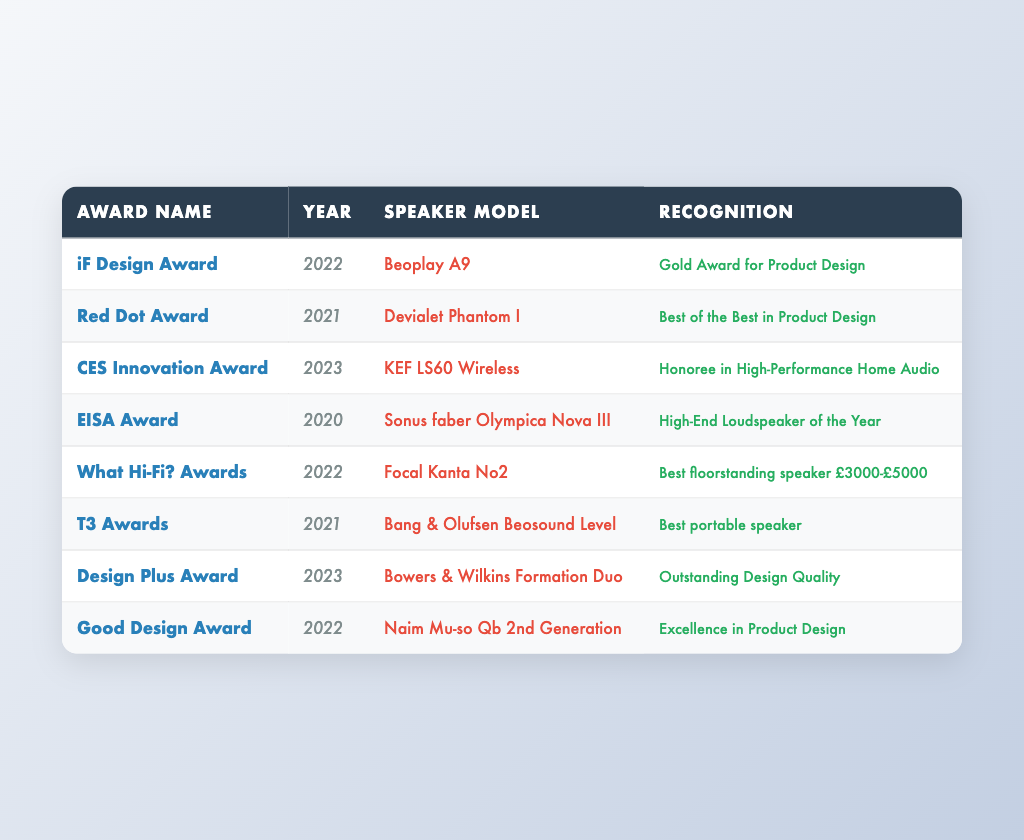What award did the Beoplay A9 receive? The Beoplay A9 received the iF Design Award in 2022, specifically recognized with the Gold Award for Product Design.
Answer: Gold Award for Product Design In which year did the KEF LS60 Wireless win an award? The KEF LS60 Wireless won the CES Innovation Award in 2023, as noted in the table.
Answer: 2023 Which speaker model was recognized in the What Hi-Fi? Awards for the price range between £3000-£5000? The Focal Kanta No2 is noted in the table as the Best floorstanding speaker for the price range of £3000-£5000 in the What Hi-Fi? Awards 2022.
Answer: Focal Kanta No2 How many awards were received by speakers in the year 2021? There are two awards listed for the year 2021: the Red Dot Award for the Devialet Phantom I and the T3 Award for the Bang & Olufsen Beosound Level. Hence, the total is 2 awards.
Answer: 2 Did any speaker win an award in 2020? Yes, the Sonus faber Olympica Nova III received the EISA Award in 2020, indicating a recognition for that year.
Answer: Yes Which award was given for the design quality of the Bowers & Wilkins Formation Duo? The Bowers & Wilkins Formation Duo was recognized with the Design Plus Award in 2023 for Outstanding Design Quality.
Answer: Design Plus Award What is the overall count of new award winners in 2023 compared to previous years? In 2023, two awards were received: CES Innovation Award for KEF LS60 Wireless and Design Plus Award for Bowers & Wilkins Formation Duo. Summing the previous years gives 6 awards, thus 2 new awards in 2023 brings the total to 8 unique award winners to date.
Answer: 2 Which recognition was given to the Naim Mu-so Qb 2nd Generation? The Naim Mu-so Qb 2nd Generation received the Good Design Award in 2022, which recognizes excellence in product design.
Answer: Excellence in Product Design How many awards were categorized under the "Best of" designation? There are three instances of awards categorized as "Best of": the Red Dot Award, the What Hi-Fi? Awards, and the T3 Awards highlighting "Best of the Best in Product Design", "Best floorstanding speaker", and "Best portable speaker" respectively, summing to a total of 3.
Answer: 3 